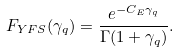Convert formula to latex. <formula><loc_0><loc_0><loc_500><loc_500>F _ { Y F S } ( \gamma _ { q } ) = \frac { e ^ { - C _ { E } \gamma _ { q } } } { \Gamma ( 1 + \gamma _ { q } ) } .</formula> 